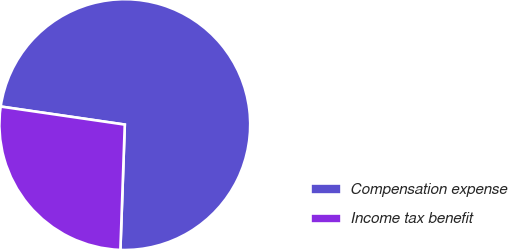<chart> <loc_0><loc_0><loc_500><loc_500><pie_chart><fcel>Compensation expense<fcel>Income tax benefit<nl><fcel>73.26%<fcel>26.74%<nl></chart> 